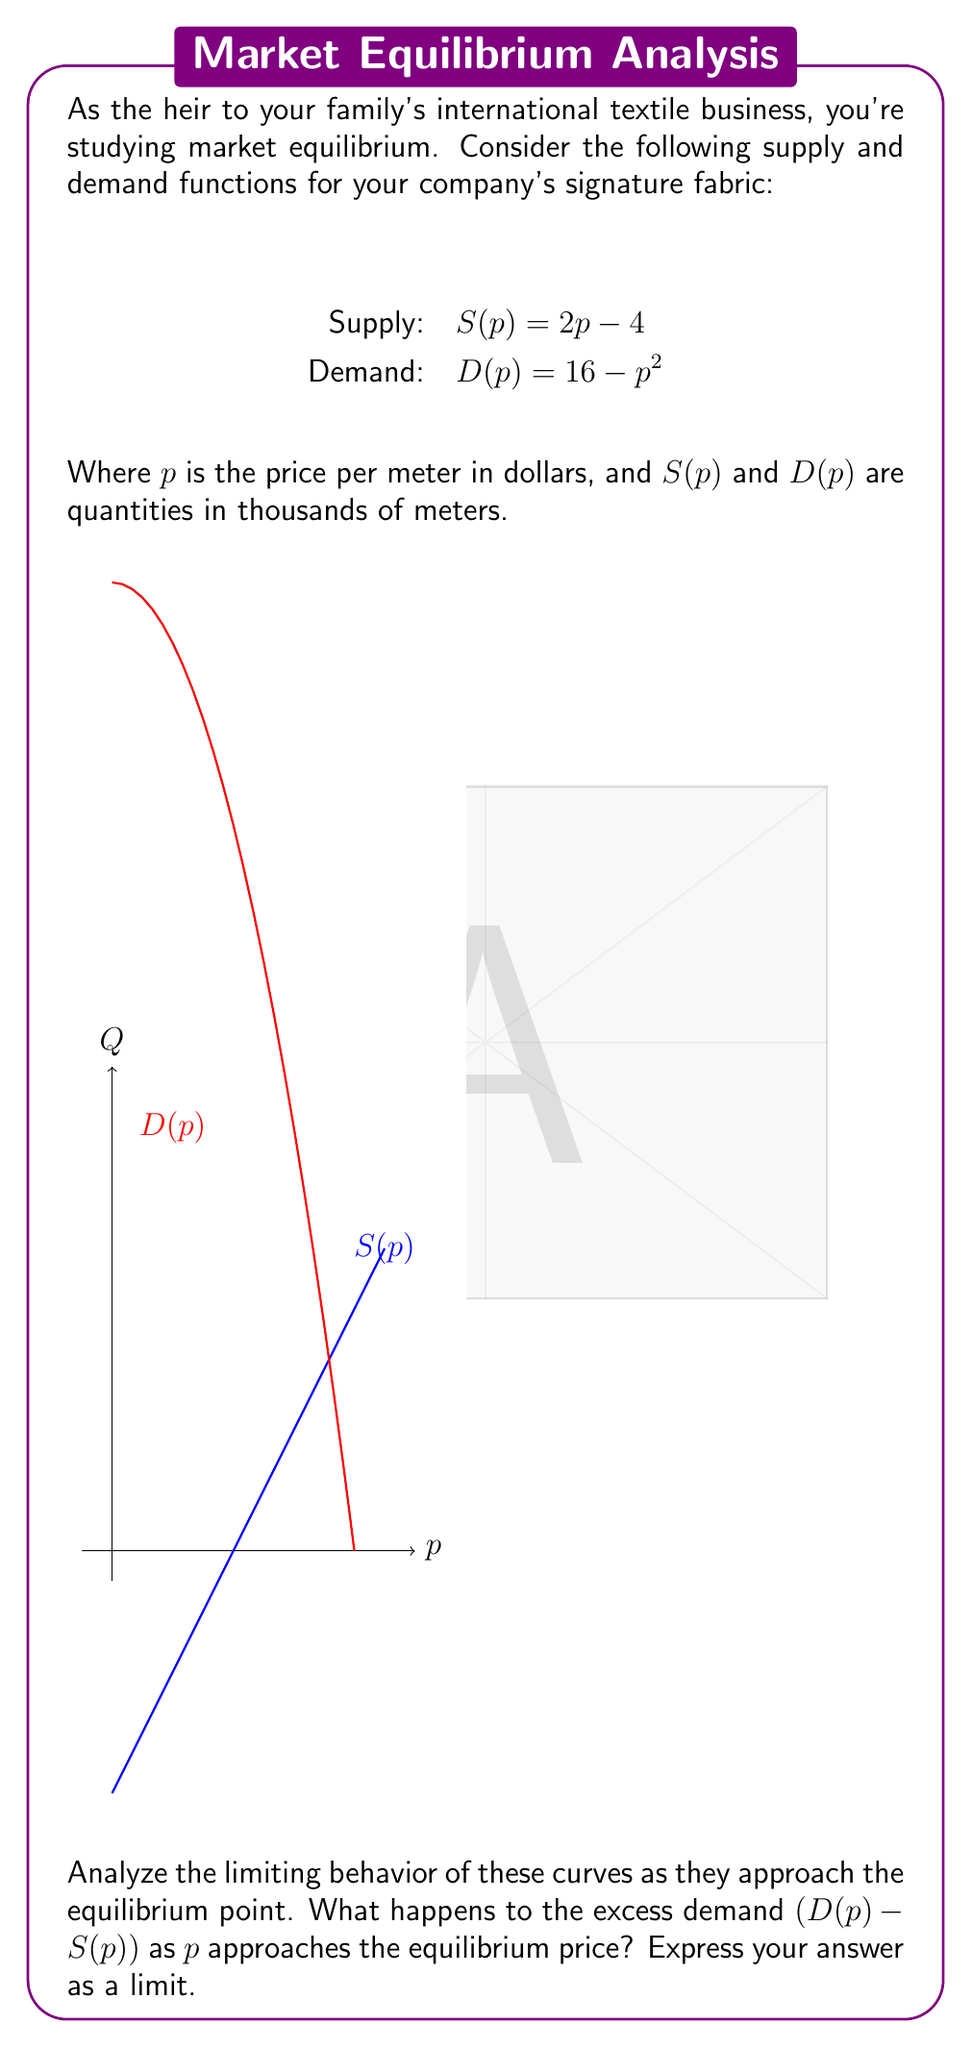Give your solution to this math problem. Let's approach this step-by-step:

1) First, we need to find the equilibrium point. This occurs where supply equals demand:

   $S(p) = D(p)$
   $2p - 4 = 16 - p^2$

2) Rearranging the equation:

   $p^2 + 2p - 20 = 0$

3) This is a quadratic equation. We can solve it using the quadratic formula:

   $p = \frac{-b \pm \sqrt{b^2 - 4ac}}{2a}$

   Here, $a=1$, $b=2$, and $c=-20$

   $p = \frac{-2 \pm \sqrt{4 + 80}}{2} = \frac{-2 \pm \sqrt{84}}{2}$

4) This gives us two solutions: $p \approx 4.59$ or $p \approx -6.59$

   Since price can't be negative, the equilibrium price is approximately 4.59.

5) Now, let's consider the excess demand function:

   $E(p) = D(p) - S(p) = (16 - p^2) - (2p - 4) = 20 - p^2 - 2p$

6) To analyze the limiting behavior, we need to consider what happens to this function as p approaches 4.59:

   $\lim_{p \to 4.59} E(p) = \lim_{p \to 4.59} (20 - p^2 - 2p)$

7) As p gets closer and closer to 4.59, E(p) will approach zero, because at the equilibrium point, supply equals demand.

Therefore, we can express this limiting behavior as:

$\lim_{p \to 4.59} (20 - p^2 - 2p) = 0$
Answer: $\lim_{p \to 4.59} (20 - p^2 - 2p) = 0$ 